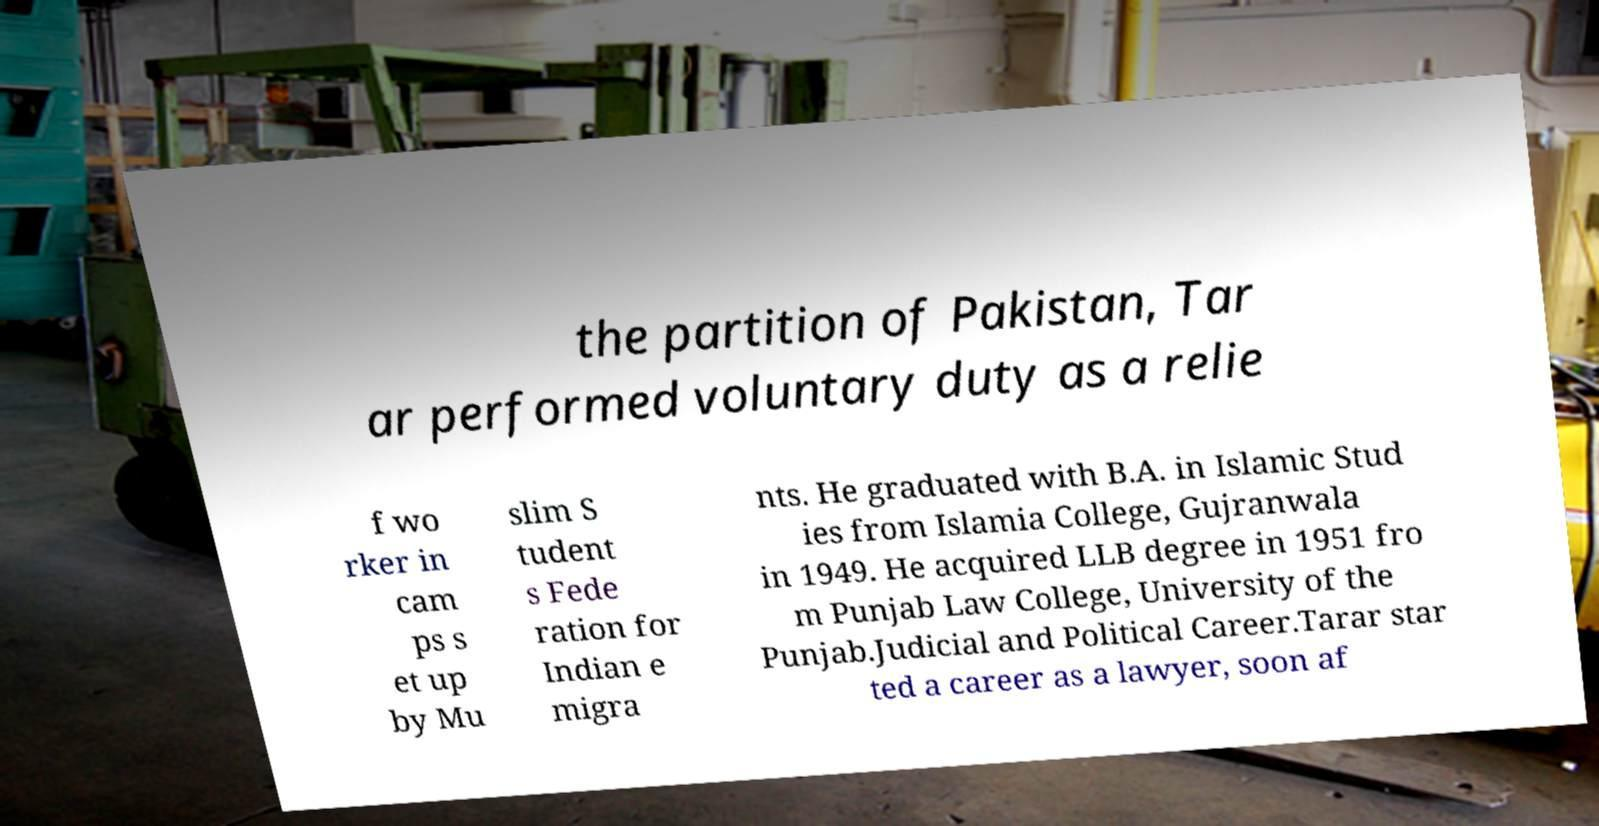Can you accurately transcribe the text from the provided image for me? the partition of Pakistan, Tar ar performed voluntary duty as a relie f wo rker in cam ps s et up by Mu slim S tudent s Fede ration for Indian e migra nts. He graduated with B.A. in Islamic Stud ies from Islamia College, Gujranwala in 1949. He acquired LLB degree in 1951 fro m Punjab Law College, University of the Punjab.Judicial and Political Career.Tarar star ted a career as a lawyer, soon af 